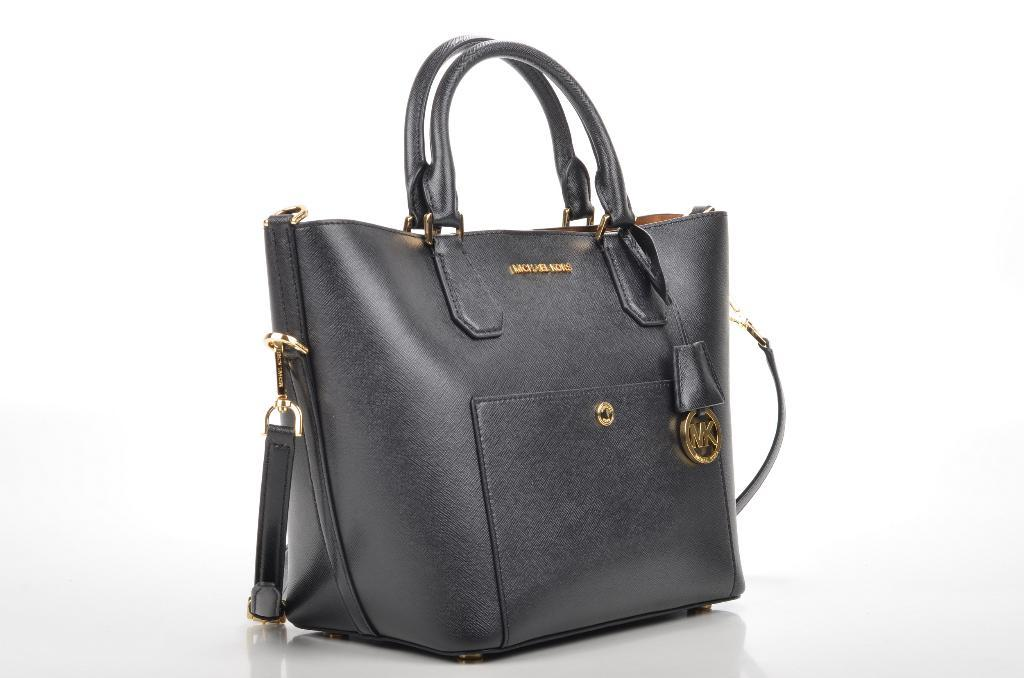What object can be seen in the image? There is a handbag in the image. What color is the handbag? The handbag is black in color. Is the handbag making any noise in the image? No, the handbag is not making any noise in the image. What shape is the handbag in the image? The provided facts do not mention the shape of the handbag, so we cannot determine its shape from the image. 